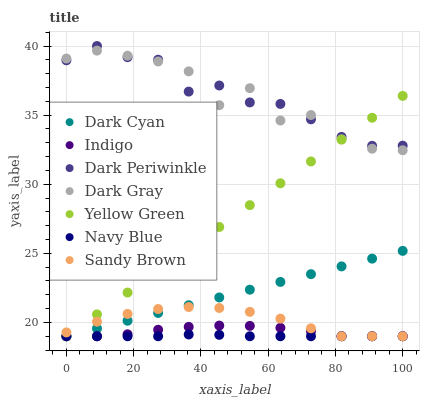Does Navy Blue have the minimum area under the curve?
Answer yes or no. Yes. Does Dark Periwinkle have the maximum area under the curve?
Answer yes or no. Yes. Does Yellow Green have the minimum area under the curve?
Answer yes or no. No. Does Yellow Green have the maximum area under the curve?
Answer yes or no. No. Is Yellow Green the smoothest?
Answer yes or no. Yes. Is Dark Gray the roughest?
Answer yes or no. Yes. Is Navy Blue the smoothest?
Answer yes or no. No. Is Navy Blue the roughest?
Answer yes or no. No. Does Indigo have the lowest value?
Answer yes or no. Yes. Does Dark Gray have the lowest value?
Answer yes or no. No. Does Dark Periwinkle have the highest value?
Answer yes or no. Yes. Does Yellow Green have the highest value?
Answer yes or no. No. Is Indigo less than Dark Periwinkle?
Answer yes or no. Yes. Is Dark Periwinkle greater than Sandy Brown?
Answer yes or no. Yes. Does Sandy Brown intersect Dark Cyan?
Answer yes or no. Yes. Is Sandy Brown less than Dark Cyan?
Answer yes or no. No. Is Sandy Brown greater than Dark Cyan?
Answer yes or no. No. Does Indigo intersect Dark Periwinkle?
Answer yes or no. No. 